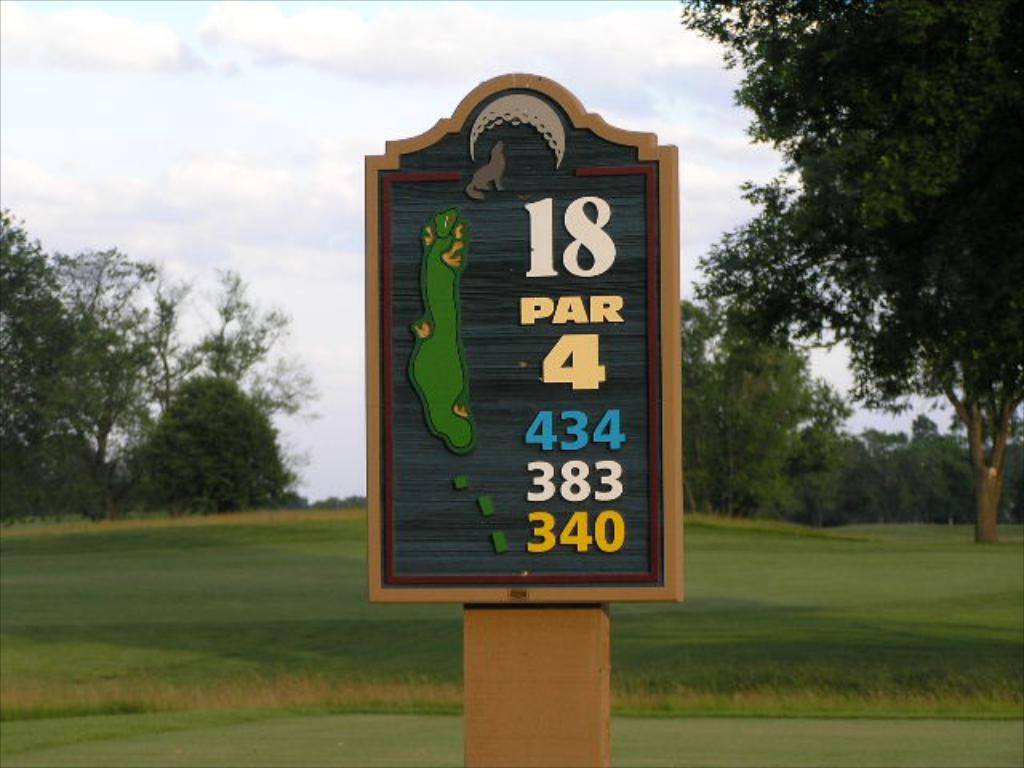<image>
Give a short and clear explanation of the subsequent image. A brown and black sign that reads 18 par 4 on its face. 